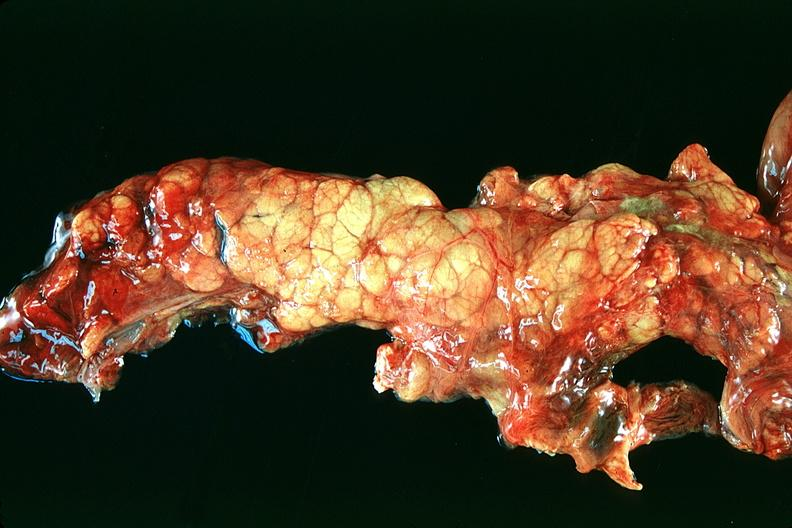what does this image show?
Answer the question using a single word or phrase. Normal pancreas 